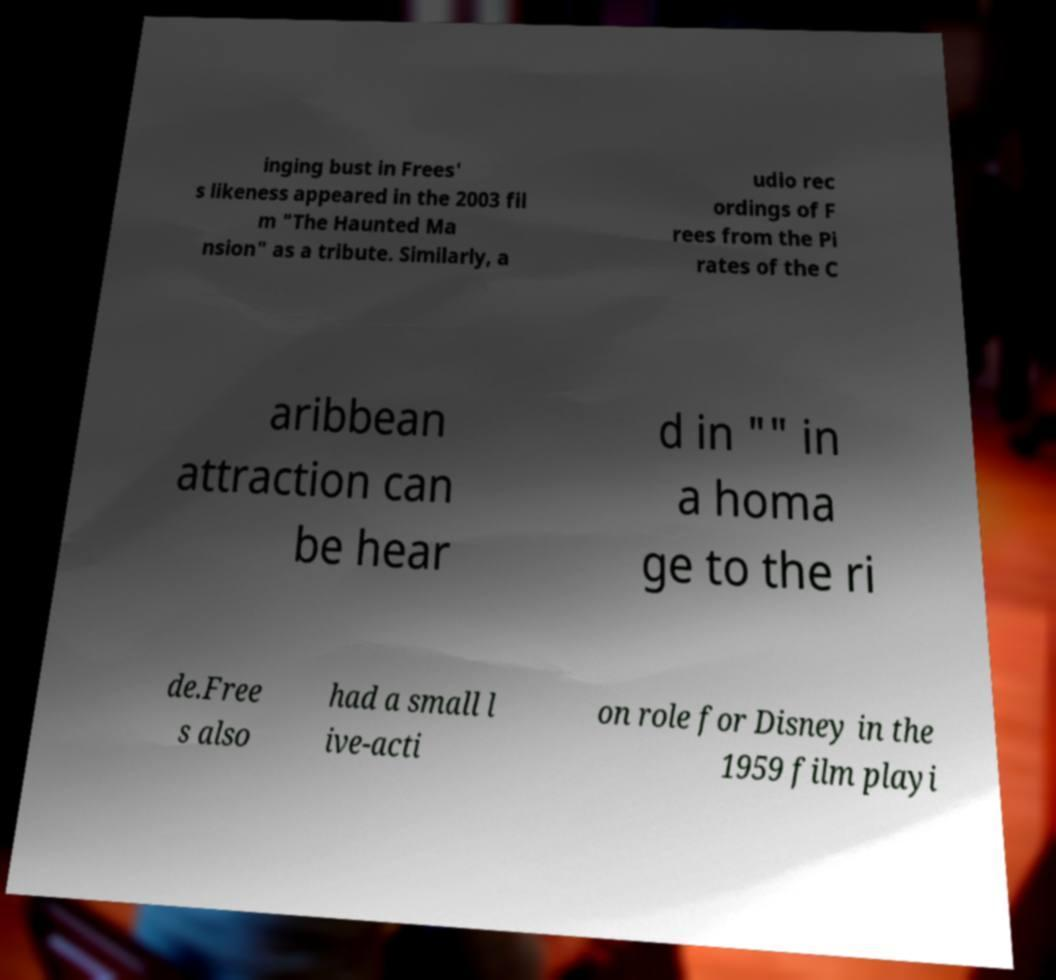Could you extract and type out the text from this image? inging bust in Frees' s likeness appeared in the 2003 fil m "The Haunted Ma nsion" as a tribute. Similarly, a udio rec ordings of F rees from the Pi rates of the C aribbean attraction can be hear d in "" in a homa ge to the ri de.Free s also had a small l ive-acti on role for Disney in the 1959 film playi 